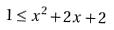Convert formula to latex. <formula><loc_0><loc_0><loc_500><loc_500>1 \leq x ^ { 2 } + 2 x + 2</formula> 